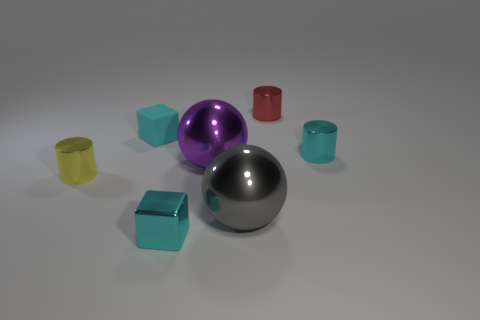The other shiny thing that is the same shape as the big gray object is what size?
Your answer should be very brief. Large. Are there an equal number of tiny red metal objects that are behind the big purple sphere and small cyan rubber cylinders?
Provide a short and direct response. No. Do the tiny object in front of the big gray ball and the yellow thing have the same shape?
Make the answer very short. No. The rubber object has what shape?
Give a very brief answer. Cube. There is a large sphere in front of the ball behind the object that is on the left side of the cyan matte thing; what is its material?
Provide a short and direct response. Metal. There is a cylinder that is the same color as the matte object; what is its material?
Your response must be concise. Metal. How many objects are shiny balls or small cyan metal things?
Offer a very short reply. 4. Do the object that is right of the red object and the tiny yellow cylinder have the same material?
Provide a short and direct response. Yes. What number of objects are metal cylinders that are on the left side of the tiny rubber cube or small red objects?
Keep it short and to the point. 2. There is a block that is the same material as the tiny yellow cylinder; what is its color?
Give a very brief answer. Cyan. 